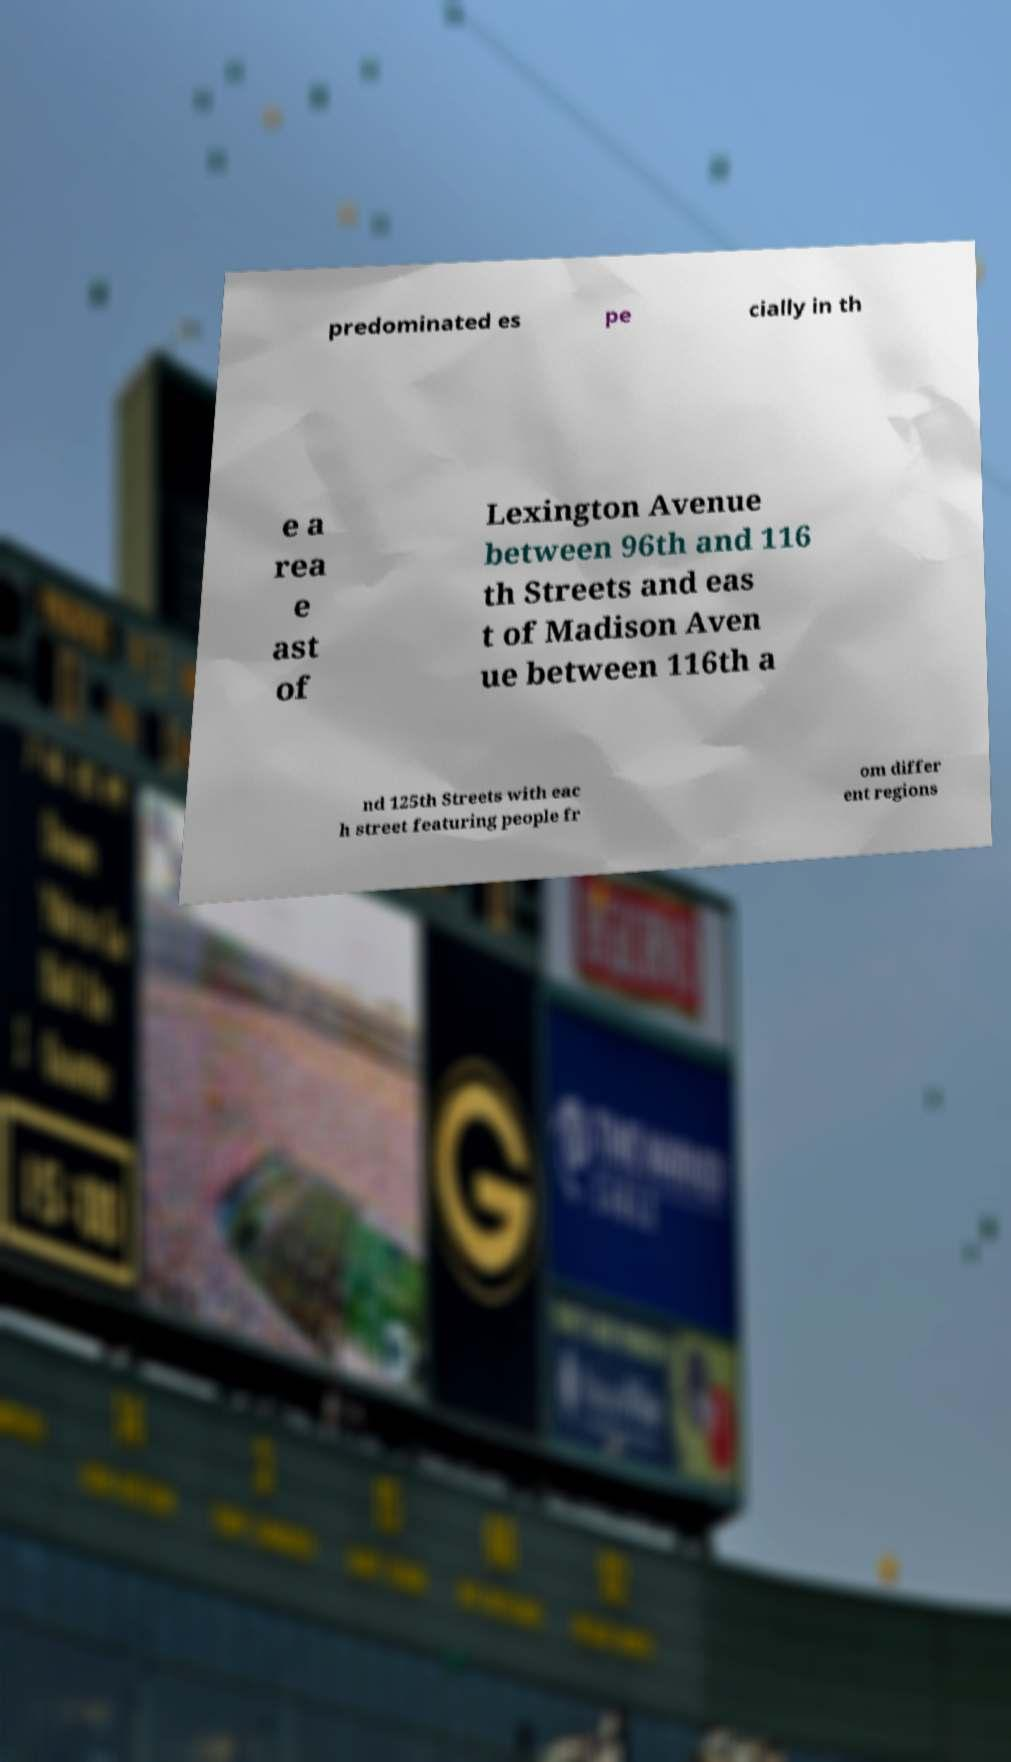Could you assist in decoding the text presented in this image and type it out clearly? predominated es pe cially in th e a rea e ast of Lexington Avenue between 96th and 116 th Streets and eas t of Madison Aven ue between 116th a nd 125th Streets with eac h street featuring people fr om differ ent regions 